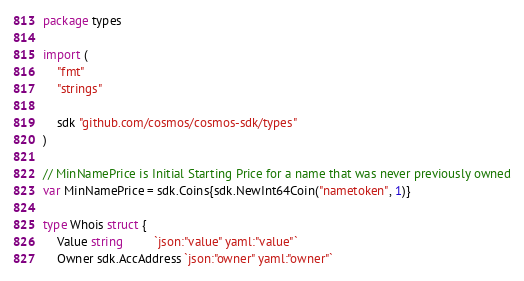Convert code to text. <code><loc_0><loc_0><loc_500><loc_500><_Go_>package types

import (
	"fmt"
	"strings"

	sdk "github.com/cosmos/cosmos-sdk/types"
)

// MinNamePrice is Initial Starting Price for a name that was never previously owned
var MinNamePrice = sdk.Coins{sdk.NewInt64Coin("nametoken", 1)}

type Whois struct {
	Value string         `json:"value" yaml:"value"`
	Owner sdk.AccAddress `json:"owner" yaml:"owner"`</code> 